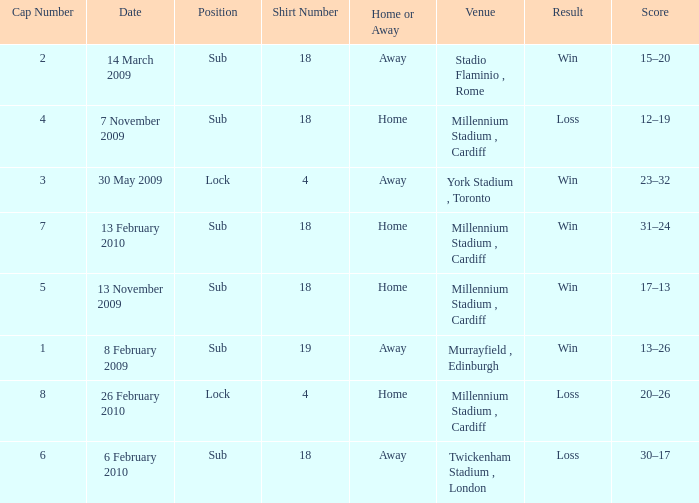Can you tell me the Score that has the Result of win, and the Date of 13 november 2009? 17–13. 